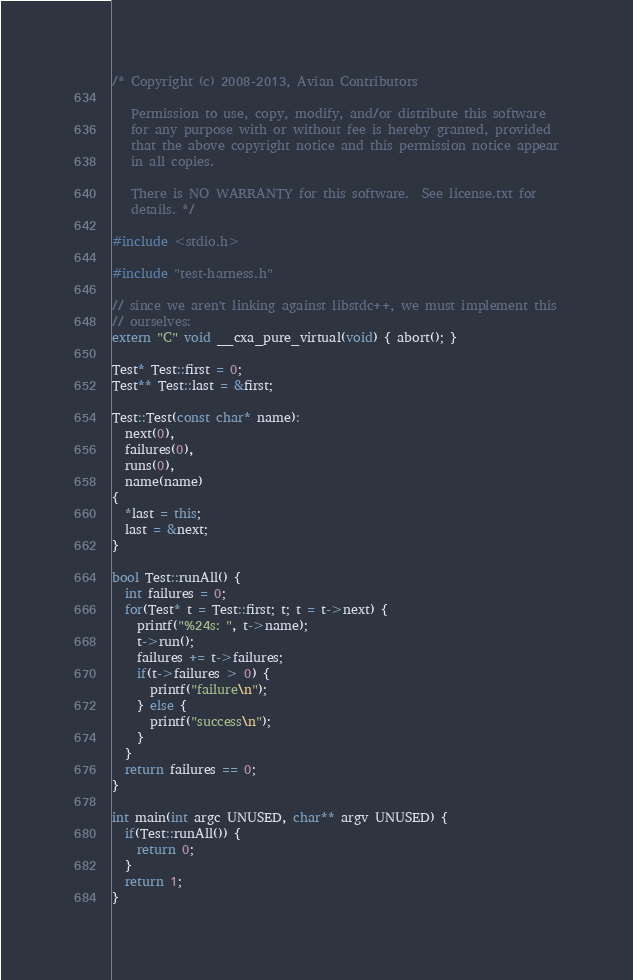Convert code to text. <code><loc_0><loc_0><loc_500><loc_500><_C++_>/* Copyright (c) 2008-2013, Avian Contributors

   Permission to use, copy, modify, and/or distribute this software
   for any purpose with or without fee is hereby granted, provided
   that the above copyright notice and this permission notice appear
   in all copies.

   There is NO WARRANTY for this software.  See license.txt for
   details. */

#include <stdio.h>

#include "test-harness.h"

// since we aren't linking against libstdc++, we must implement this
// ourselves:
extern "C" void __cxa_pure_virtual(void) { abort(); }

Test* Test::first = 0;
Test** Test::last = &first;

Test::Test(const char* name):
  next(0),
  failures(0),
  runs(0),
  name(name)
{
  *last = this;
  last = &next;
}

bool Test::runAll() {
  int failures = 0;
  for(Test* t = Test::first; t; t = t->next) {
    printf("%24s: ", t->name);
    t->run();
    failures += t->failures;
    if(t->failures > 0) {
      printf("failure\n");
    } else {
      printf("success\n");
    }
  }
  return failures == 0;
}

int main(int argc UNUSED, char** argv UNUSED) {
  if(Test::runAll()) {
    return 0;
  }
  return 1;
}</code> 